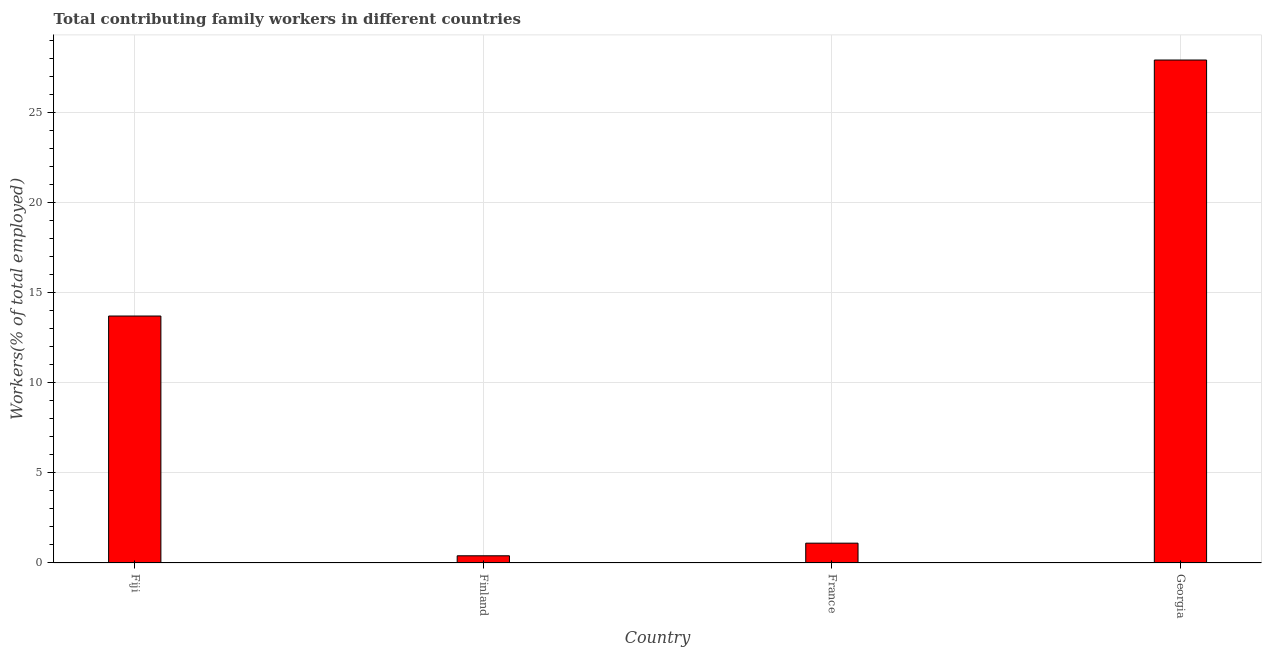Does the graph contain any zero values?
Give a very brief answer. No. Does the graph contain grids?
Provide a short and direct response. Yes. What is the title of the graph?
Your response must be concise. Total contributing family workers in different countries. What is the label or title of the X-axis?
Provide a short and direct response. Country. What is the label or title of the Y-axis?
Ensure brevity in your answer.  Workers(% of total employed). What is the contributing family workers in Fiji?
Your response must be concise. 13.7. Across all countries, what is the maximum contributing family workers?
Provide a succinct answer. 27.9. Across all countries, what is the minimum contributing family workers?
Offer a terse response. 0.4. In which country was the contributing family workers maximum?
Provide a succinct answer. Georgia. In which country was the contributing family workers minimum?
Your response must be concise. Finland. What is the sum of the contributing family workers?
Ensure brevity in your answer.  43.1. What is the difference between the contributing family workers in France and Georgia?
Keep it short and to the point. -26.8. What is the average contributing family workers per country?
Your response must be concise. 10.78. What is the median contributing family workers?
Give a very brief answer. 7.4. What is the ratio of the contributing family workers in France to that in Georgia?
Provide a short and direct response. 0.04. Is the contributing family workers in Finland less than that in France?
Give a very brief answer. Yes. Is the sum of the contributing family workers in Fiji and Georgia greater than the maximum contributing family workers across all countries?
Your answer should be compact. Yes. What is the difference between the highest and the lowest contributing family workers?
Ensure brevity in your answer.  27.5. How many bars are there?
Your answer should be very brief. 4. How many countries are there in the graph?
Make the answer very short. 4. Are the values on the major ticks of Y-axis written in scientific E-notation?
Ensure brevity in your answer.  No. What is the Workers(% of total employed) of Fiji?
Your answer should be compact. 13.7. What is the Workers(% of total employed) in Finland?
Provide a short and direct response. 0.4. What is the Workers(% of total employed) in France?
Ensure brevity in your answer.  1.1. What is the Workers(% of total employed) in Georgia?
Your answer should be compact. 27.9. What is the difference between the Workers(% of total employed) in Fiji and France?
Your response must be concise. 12.6. What is the difference between the Workers(% of total employed) in Fiji and Georgia?
Provide a succinct answer. -14.2. What is the difference between the Workers(% of total employed) in Finland and Georgia?
Provide a succinct answer. -27.5. What is the difference between the Workers(% of total employed) in France and Georgia?
Give a very brief answer. -26.8. What is the ratio of the Workers(% of total employed) in Fiji to that in Finland?
Your answer should be very brief. 34.25. What is the ratio of the Workers(% of total employed) in Fiji to that in France?
Offer a very short reply. 12.46. What is the ratio of the Workers(% of total employed) in Fiji to that in Georgia?
Offer a very short reply. 0.49. What is the ratio of the Workers(% of total employed) in Finland to that in France?
Your answer should be very brief. 0.36. What is the ratio of the Workers(% of total employed) in Finland to that in Georgia?
Provide a succinct answer. 0.01. What is the ratio of the Workers(% of total employed) in France to that in Georgia?
Your answer should be compact. 0.04. 